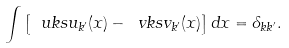<formula> <loc_0><loc_0><loc_500><loc_500>\int \left [ \ u k s u _ { k ^ { \prime } } ( x ) - \ v k s v _ { k ^ { \prime } } ( x ) \right ] d x = \delta _ { k k ^ { \prime } } .</formula> 